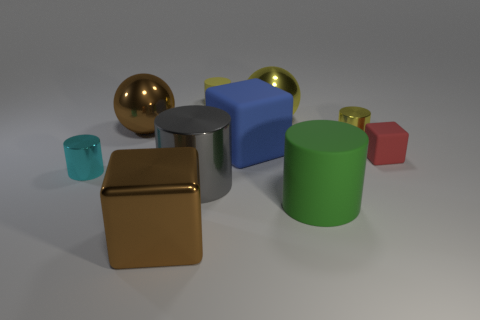The tiny thing behind the large brown thing behind the gray cylinder is what color?
Keep it short and to the point. Yellow. Do the brown ball and the cyan thing have the same size?
Give a very brief answer. No. What number of cylinders are small yellow shiny things or big objects?
Offer a terse response. 3. What number of tiny metal cylinders are to the right of the rubber block on the right side of the green matte object?
Your answer should be very brief. 0. Is the yellow rubber object the same shape as the tiny cyan thing?
Ensure brevity in your answer.  Yes. What is the size of the green object that is the same shape as the cyan metal thing?
Give a very brief answer. Large. There is a big brown object behind the small thing in front of the red object; what shape is it?
Your answer should be compact. Sphere. The red rubber object is what size?
Keep it short and to the point. Small. What is the shape of the gray metallic object?
Your answer should be very brief. Cylinder. Does the blue object have the same shape as the big brown thing that is in front of the yellow metallic cylinder?
Ensure brevity in your answer.  Yes. 